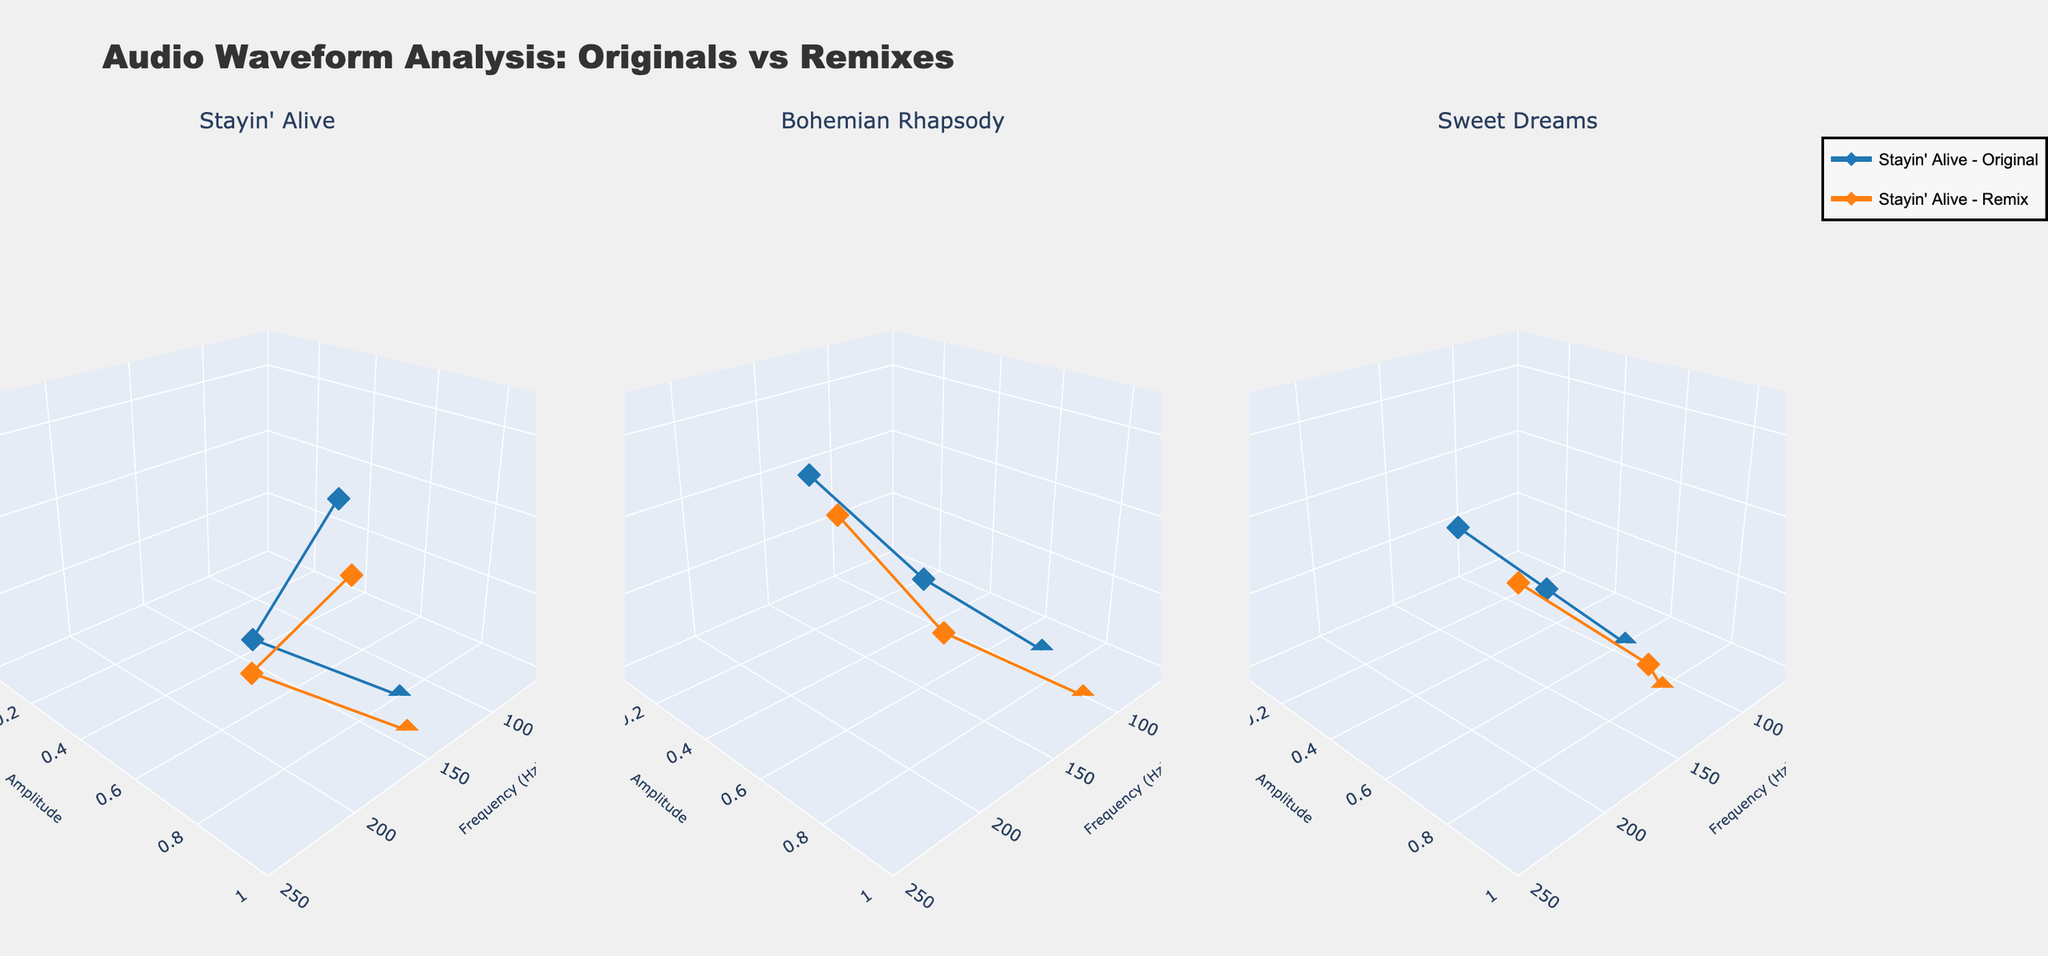What's the title of the figure? The title is displayed prominently at the top of the figure and reads "Audio Waveform Analysis: Originals vs Remixes".
Answer: Audio Waveform Analysis: Originals vs Remixes Which song has the highest frequency in its remix version? By examining the highest point on the frequency axis for the remix versions across all subplots, the highest frequency is found in the "Sweet Dreams" remix with a frequency of 190 Hz.
Answer: Sweet Dreams How many versions of each song are plotted? Each subplot has two versions plotted, "Original" and "Remix", hence there are 2 versions per song.
Answer: 2 What is the amplitude of "Bohemian Rhapsody" at time 3 seconds for the remix version? In the "Bohemian Rhapsody" subplot, locate the point at 3 seconds along the time axis for the remix version, which shows an amplitude of 0.8.
Answer: 0.8 Compare the amplitudes of "Stayin' Alive" original and remix versions at time 2 seconds. Which one is higher? At 2 seconds, the amplitude of the original version of "Stayin' Alive" is 0.6, whereas for the remix version it is 0.7. The remix version has a higher amplitude.
Answer: Remix What is the average frequency of "Sweet Dreams" original version across all time points? For "Sweet Dreams" original version, the frequencies are 90 Hz, 130 Hz, and 170 Hz. The average frequency is calculated as (90 + 130 + 170) / 3 = 130 Hz.
Answer: 130 Hz Which version of "Stayin' Alive" has the lowest amplitude and at what time? The "Stayin' Alive" original version has the lowest amplitude of 0.5 at time 4 seconds.
Answer: Original, 4 seconds What is the maximum frequency noted for "Bohemian Rhapsody" original version, and at what time does it occur? By checking the frequency values of the "Bohemian Rhapsody" original version, the highest frequency is 200 Hz, which occurs at 6 seconds.
Answer: 200 Hz, 6 seconds Find the difference in frequency between the original and remix versions of "Stayin' Alive" at time 0 seconds. At 0 seconds, the frequencies are 120 Hz for the original and 140 Hz for the remix version of "Stayin' Alive". The difference is 140 - 120 = 20 Hz.
Answer: 20 Hz 